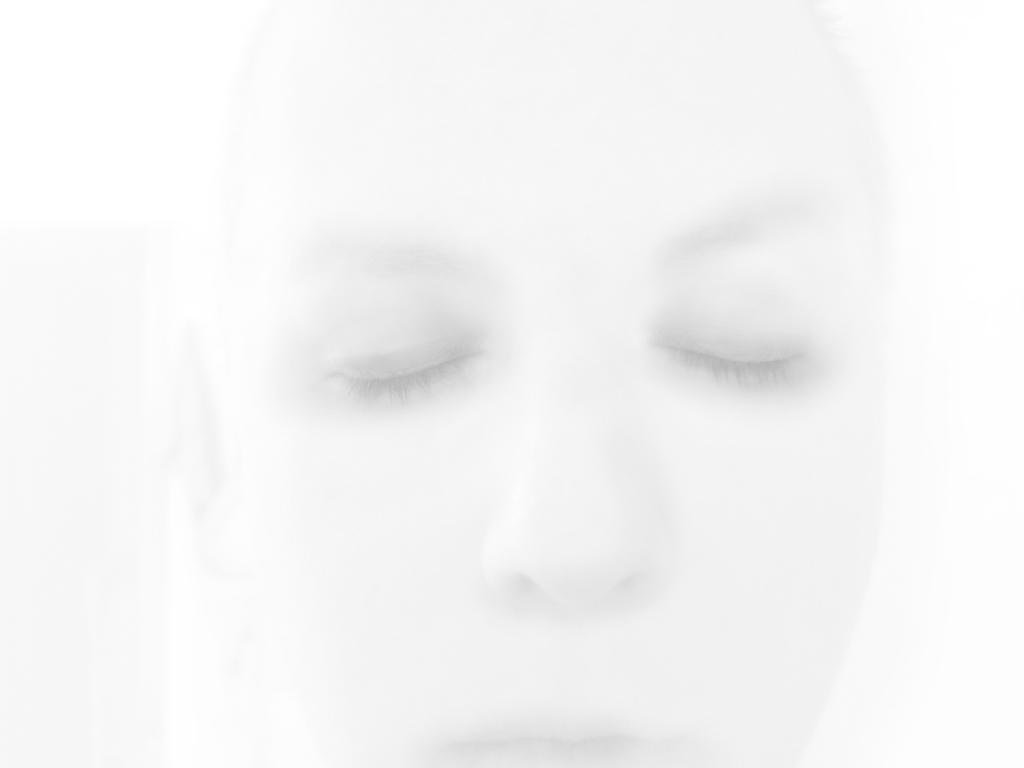Could you give a brief overview of what you see in this image? In this black and white picture there is a person. 